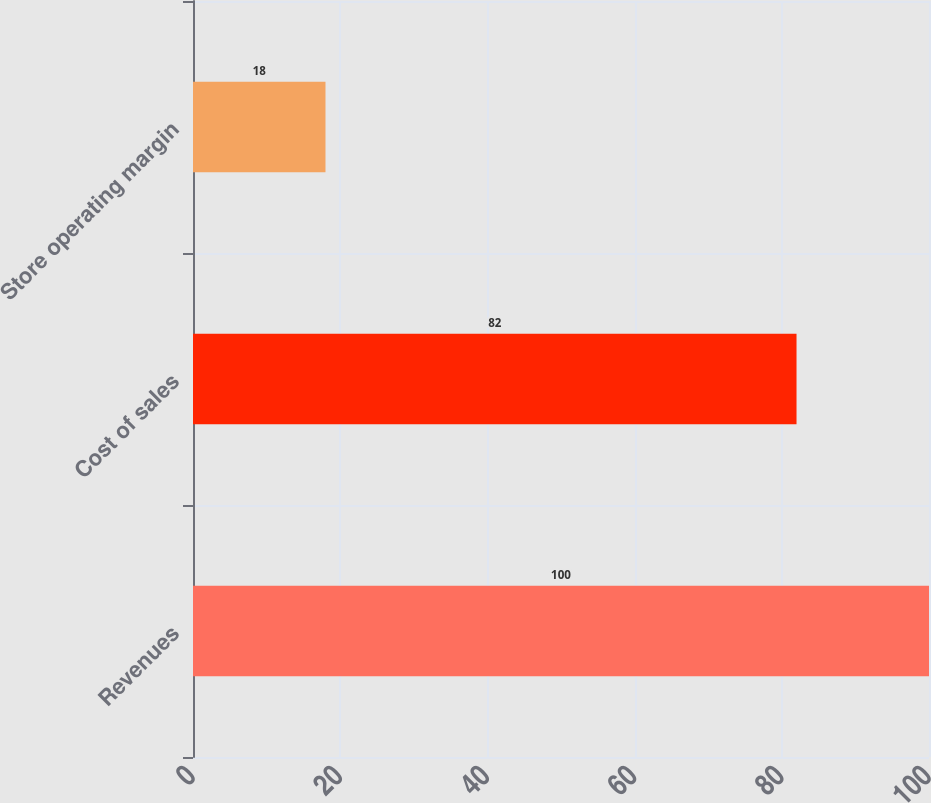<chart> <loc_0><loc_0><loc_500><loc_500><bar_chart><fcel>Revenues<fcel>Cost of sales<fcel>Store operating margin<nl><fcel>100<fcel>82<fcel>18<nl></chart> 